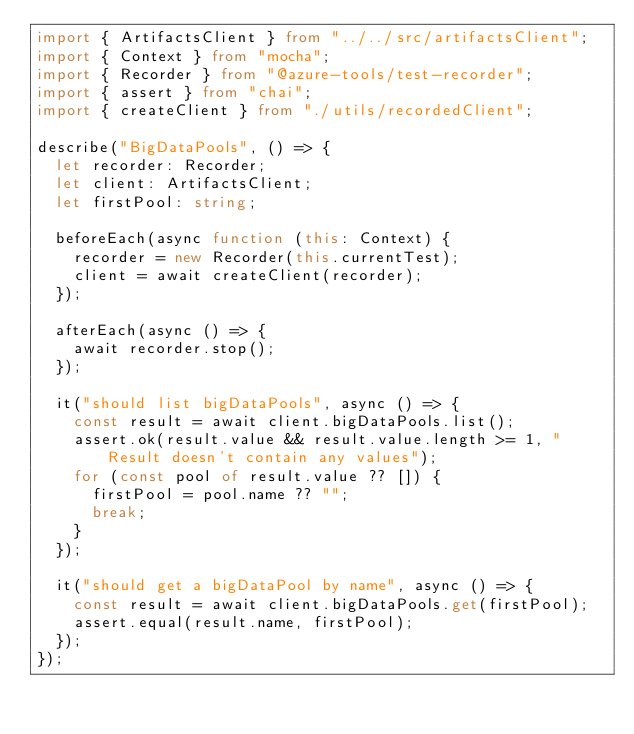Convert code to text. <code><loc_0><loc_0><loc_500><loc_500><_TypeScript_>import { ArtifactsClient } from "../../src/artifactsClient";
import { Context } from "mocha";
import { Recorder } from "@azure-tools/test-recorder";
import { assert } from "chai";
import { createClient } from "./utils/recordedClient";

describe("BigDataPools", () => {
  let recorder: Recorder;
  let client: ArtifactsClient;
  let firstPool: string;

  beforeEach(async function (this: Context) {
    recorder = new Recorder(this.currentTest);
    client = await createClient(recorder);
  });

  afterEach(async () => {
    await recorder.stop();
  });

  it("should list bigDataPools", async () => {
    const result = await client.bigDataPools.list();
    assert.ok(result.value && result.value.length >= 1, "Result doesn't contain any values");
    for (const pool of result.value ?? []) {
      firstPool = pool.name ?? "";
      break;
    }
  });

  it("should get a bigDataPool by name", async () => {
    const result = await client.bigDataPools.get(firstPool);
    assert.equal(result.name, firstPool);
  });
});
</code> 